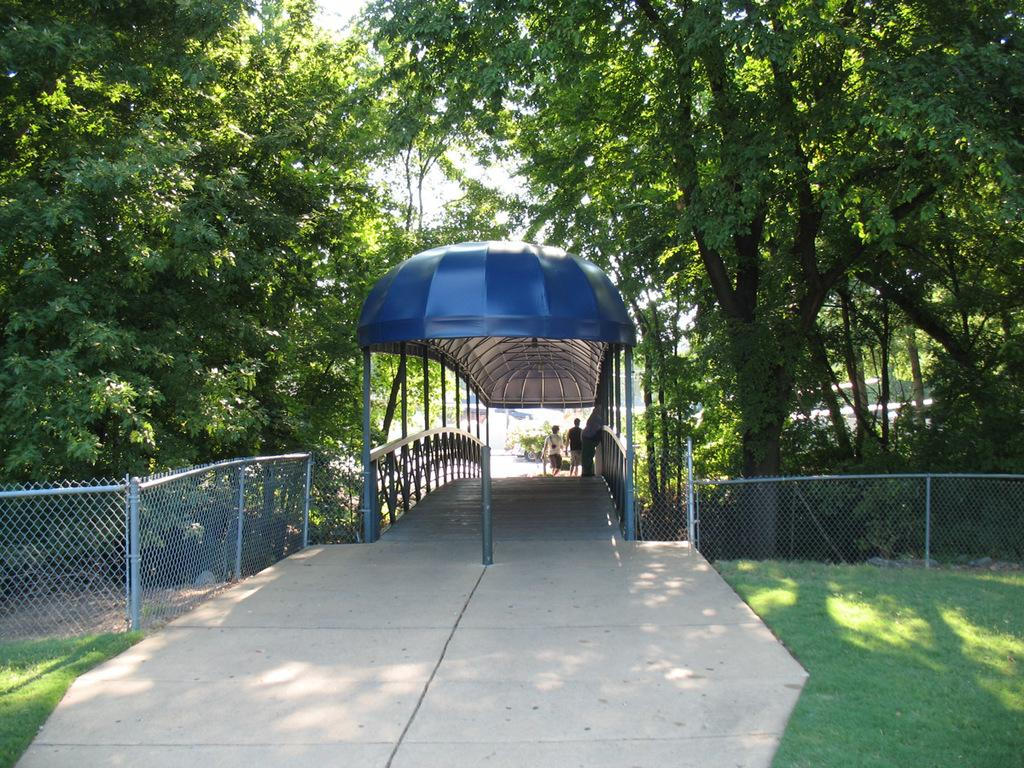How many people are present in the image? There are two people in the image. What type of natural environment can be seen in the image? There are trees and grass visible in the image. What architectural feature is present in the image? There is a fence in the image. What part of the natural environment is visible in the image? The ground and sky are visible in the image. What type of discovery was made by the people in the image? There is no indication of a discovery being made in the image; it simply shows two people in a natural environment with a fence. What type of wall is present in the image? There is no wall present in the image; it features a fence instead. 